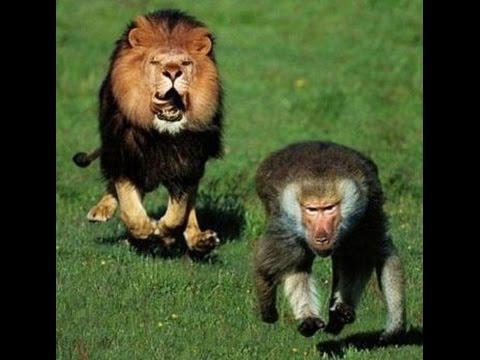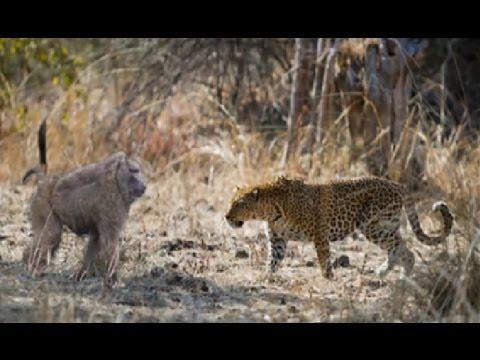The first image is the image on the left, the second image is the image on the right. Analyze the images presented: Is the assertion "There are exactly two animals in the image on the right." valid? Answer yes or no. Yes. The first image is the image on the left, the second image is the image on the right. For the images shown, is this caption "There are no more than 4 animals." true? Answer yes or no. Yes. 